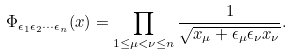Convert formula to latex. <formula><loc_0><loc_0><loc_500><loc_500>\Phi _ { \epsilon _ { 1 } \epsilon _ { 2 } \cdots \epsilon _ { n } } ( x ) = \prod _ { 1 \leq \mu < \nu \leq n } \frac { 1 } { \sqrt { x _ { \mu } + \epsilon _ { \mu } \epsilon _ { \nu } x _ { \nu } } } .</formula> 